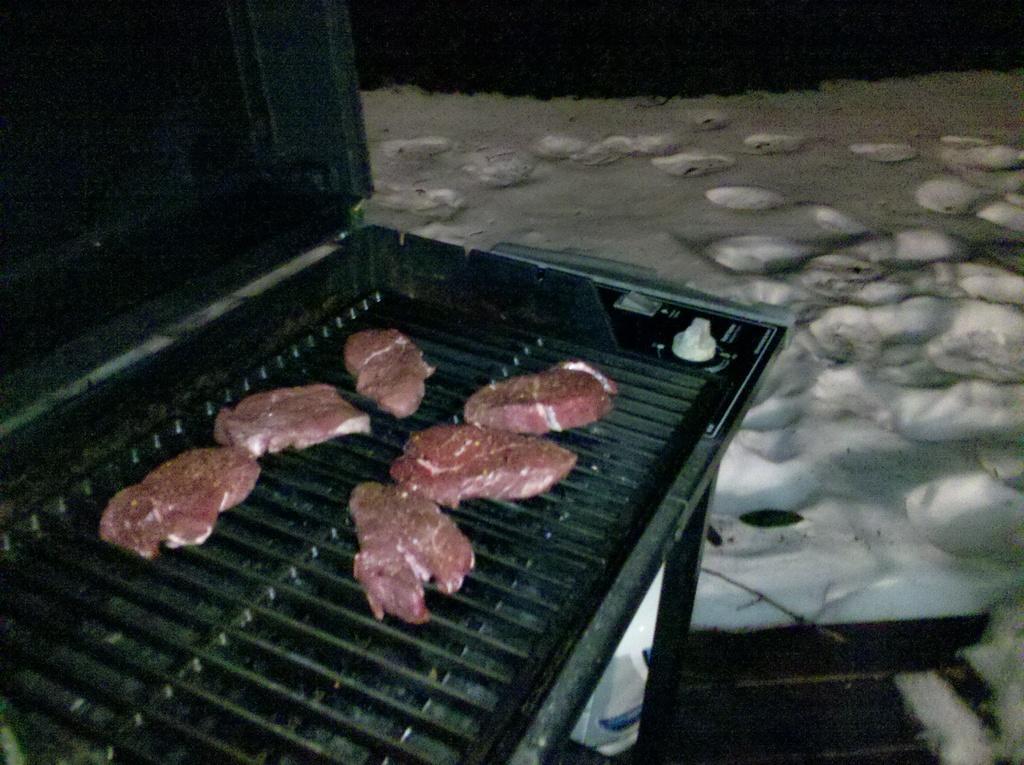Describe this image in one or two sentences. In this image we can see some a food item on a grill and there we can also see white color sand. 